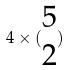Convert formula to latex. <formula><loc_0><loc_0><loc_500><loc_500>4 \times ( \begin{matrix} 5 \\ 2 \end{matrix} )</formula> 